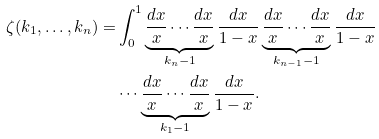<formula> <loc_0><loc_0><loc_500><loc_500>\zeta ( k _ { 1 } , \dots , k _ { n } ) = & \int _ { 0 } ^ { 1 } \underbrace { \frac { d x } { x } \cdots \frac { d x } { x } } _ { k _ { n } - 1 } \frac { d x } { 1 - x } \underbrace { \frac { d x } { x } \cdots \frac { d x } { x } } _ { k _ { n - 1 } - 1 } \frac { d x } { 1 - x } \\ & \cdots \underbrace { \frac { d x } { x } \cdots \frac { d x } { x } } _ { k _ { 1 } - 1 } \frac { d x } { 1 - x } .</formula> 